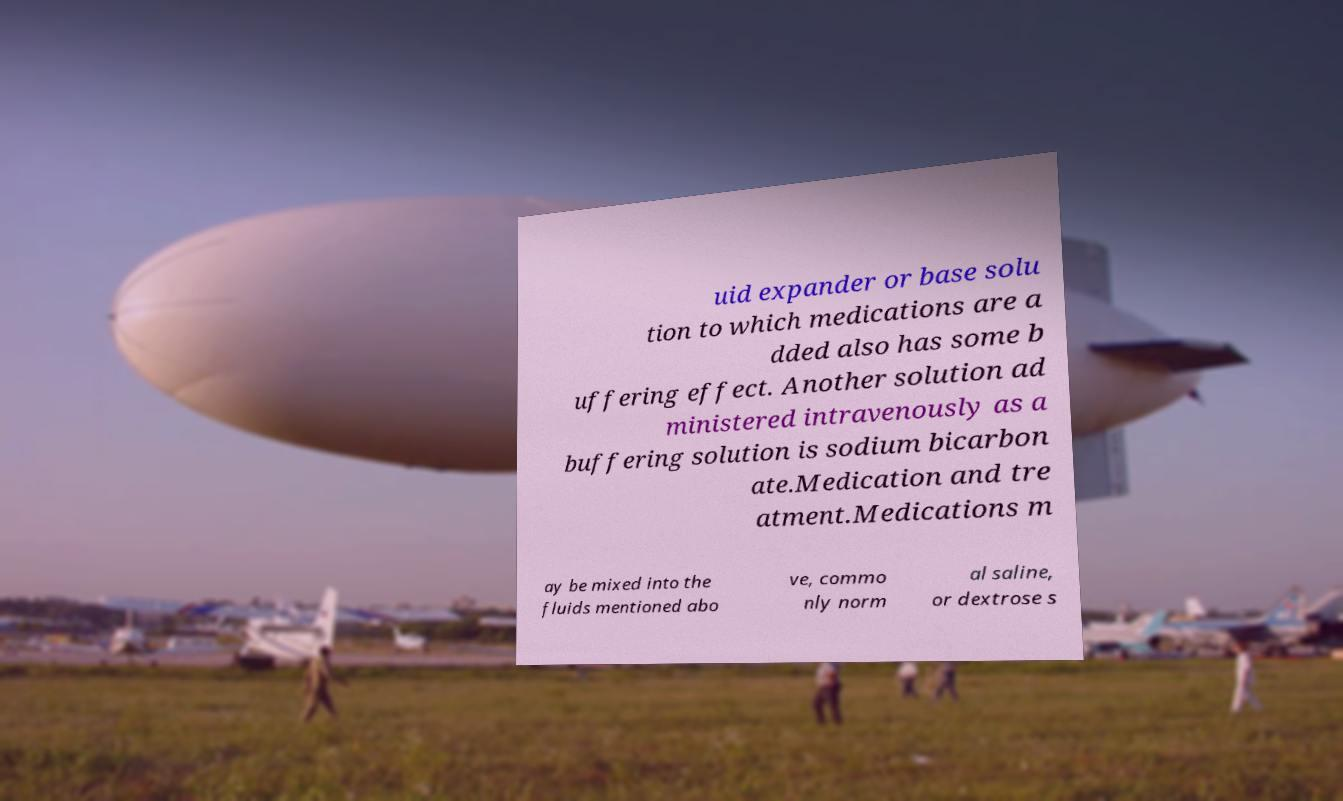Can you read and provide the text displayed in the image?This photo seems to have some interesting text. Can you extract and type it out for me? uid expander or base solu tion to which medications are a dded also has some b uffering effect. Another solution ad ministered intravenously as a buffering solution is sodium bicarbon ate.Medication and tre atment.Medications m ay be mixed into the fluids mentioned abo ve, commo nly norm al saline, or dextrose s 